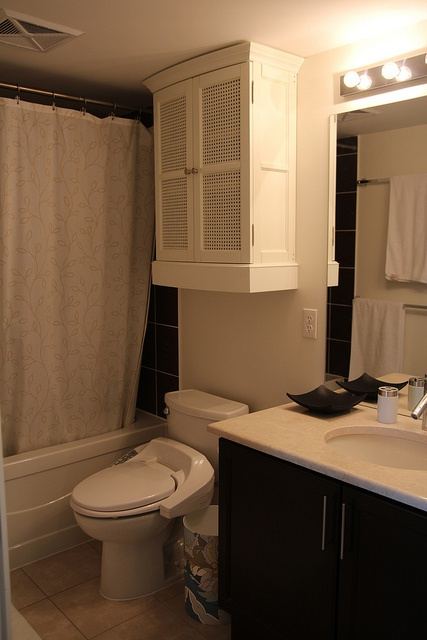Describe the objects in this image and their specific colors. I can see sink in brown, tan, and gray tones, toilet in brown, gray, maroon, and tan tones, and cup in brown, darkgray, tan, gray, and black tones in this image. 